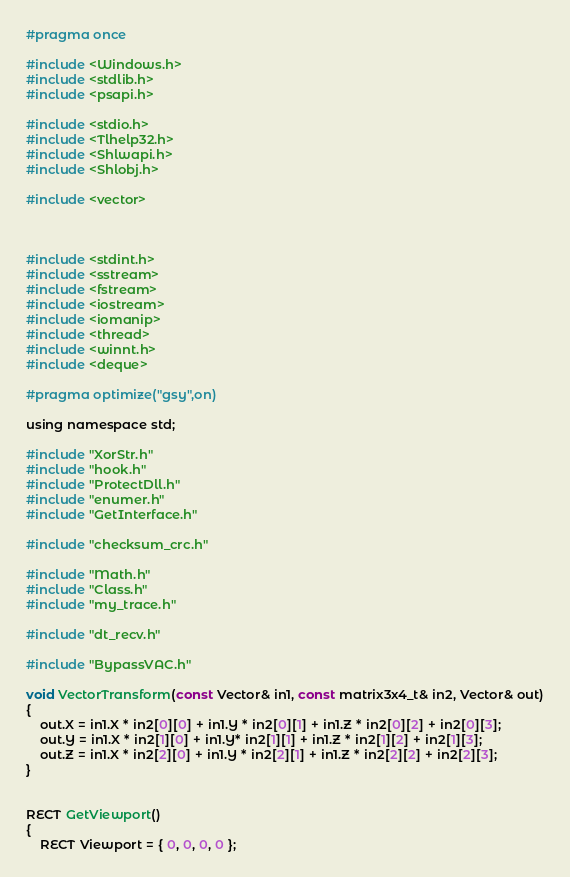<code> <loc_0><loc_0><loc_500><loc_500><_C_>#pragma once

#include <Windows.h>
#include <stdlib.h>  
#include <psapi.h>

#include <stdio.h>
#include <Tlhelp32.h>
#include <Shlwapi.h>
#include <Shlobj.h>

#include <vector>



#include <stdint.h>
#include <sstream>
#include <fstream>
#include <iostream>
#include <iomanip>
#include <thread>
#include <winnt.h>
#include <deque>

#pragma optimize("gsy",on)

using namespace std;

#include "XorStr.h"
#include "hook.h"
#include "ProtectDll.h"
#include "enumer.h"
#include "GetInterface.h"

#include "checksum_crc.h"

#include "Math.h"
#include "Class.h"
#include "my_trace.h"

#include "dt_recv.h"

#include "BypassVAC.h"

void VectorTransform(const Vector& in1, const matrix3x4_t& in2, Vector& out)
{
	out.X = in1.X * in2[0][0] + in1.Y * in2[0][1] + in1.Z * in2[0][2] + in2[0][3];
	out.Y = in1.X * in2[1][0] + in1.Y* in2[1][1] + in1.Z * in2[1][2] + in2[1][3];
	out.Z = in1.X * in2[2][0] + in1.Y * in2[2][1] + in1.Z * in2[2][2] + in2[2][3];
}


RECT GetViewport()
{
	RECT Viewport = { 0, 0, 0, 0 };	</code> 